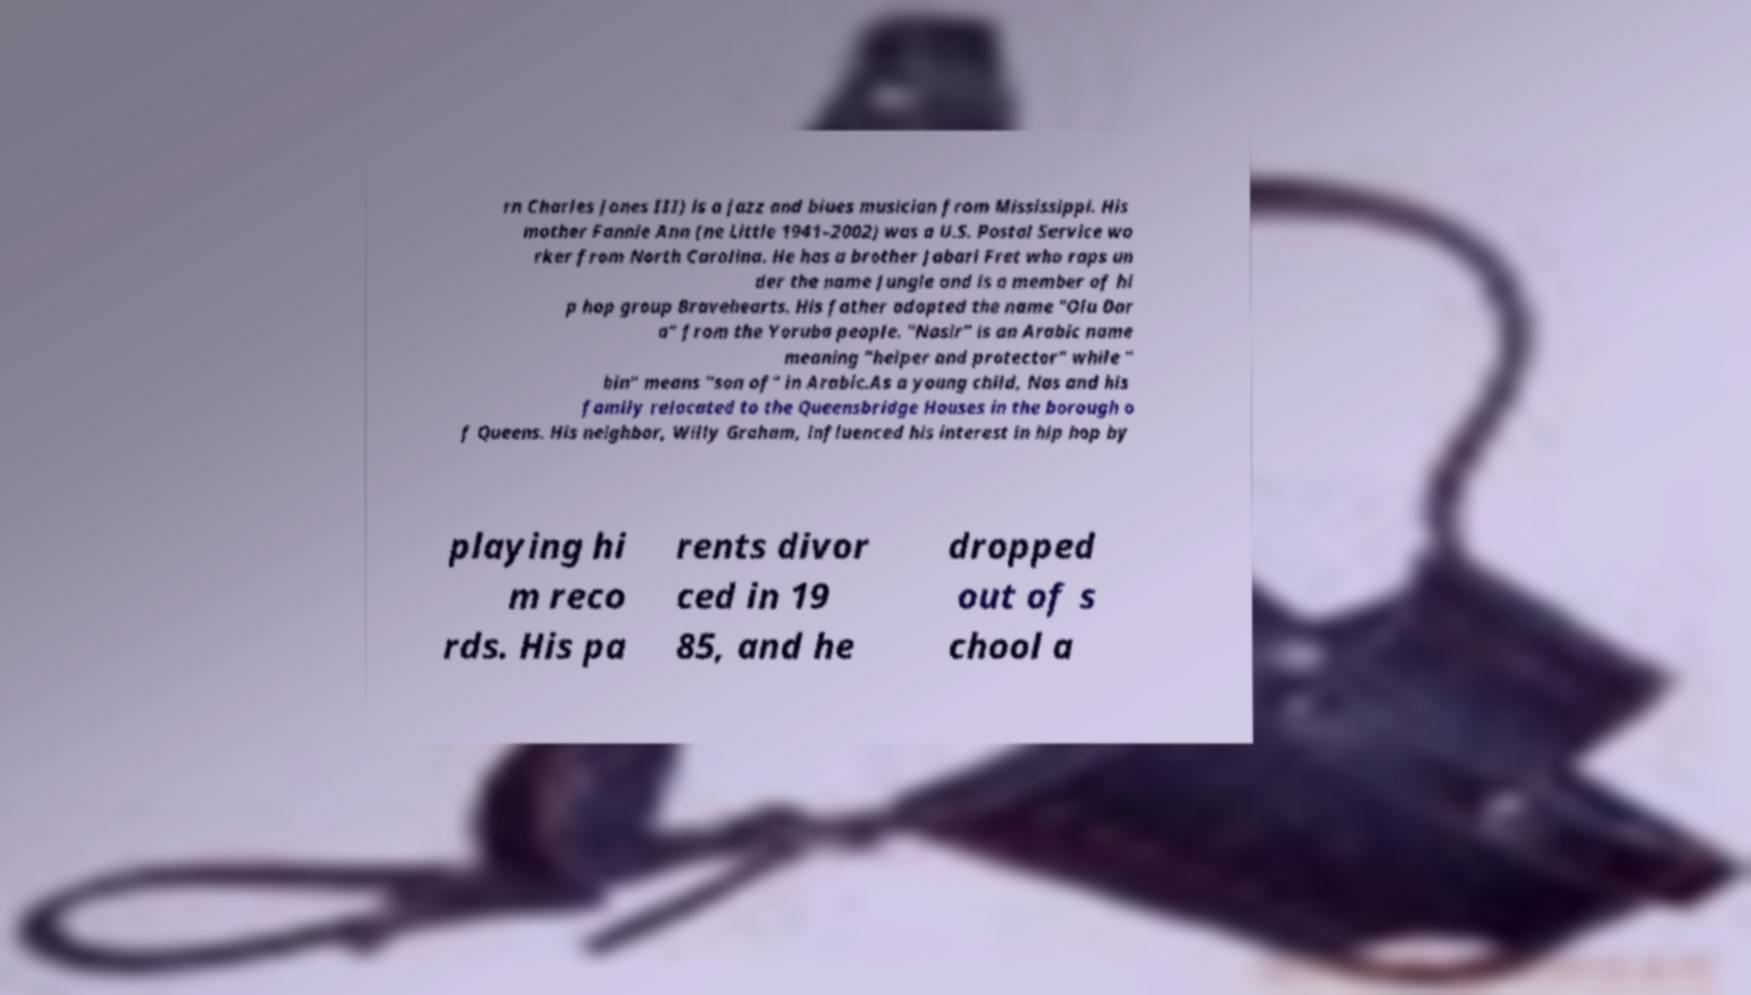There's text embedded in this image that I need extracted. Can you transcribe it verbatim? rn Charles Jones III) is a jazz and blues musician from Mississippi. His mother Fannie Ann (ne Little 1941–2002) was a U.S. Postal Service wo rker from North Carolina. He has a brother Jabari Fret who raps un der the name Jungle and is a member of hi p hop group Bravehearts. His father adopted the name "Olu Dar a" from the Yoruba people. "Nasir" is an Arabic name meaning "helper and protector" while " bin" means "son of" in Arabic.As a young child, Nas and his family relocated to the Queensbridge Houses in the borough o f Queens. His neighbor, Willy Graham, influenced his interest in hip hop by playing hi m reco rds. His pa rents divor ced in 19 85, and he dropped out of s chool a 